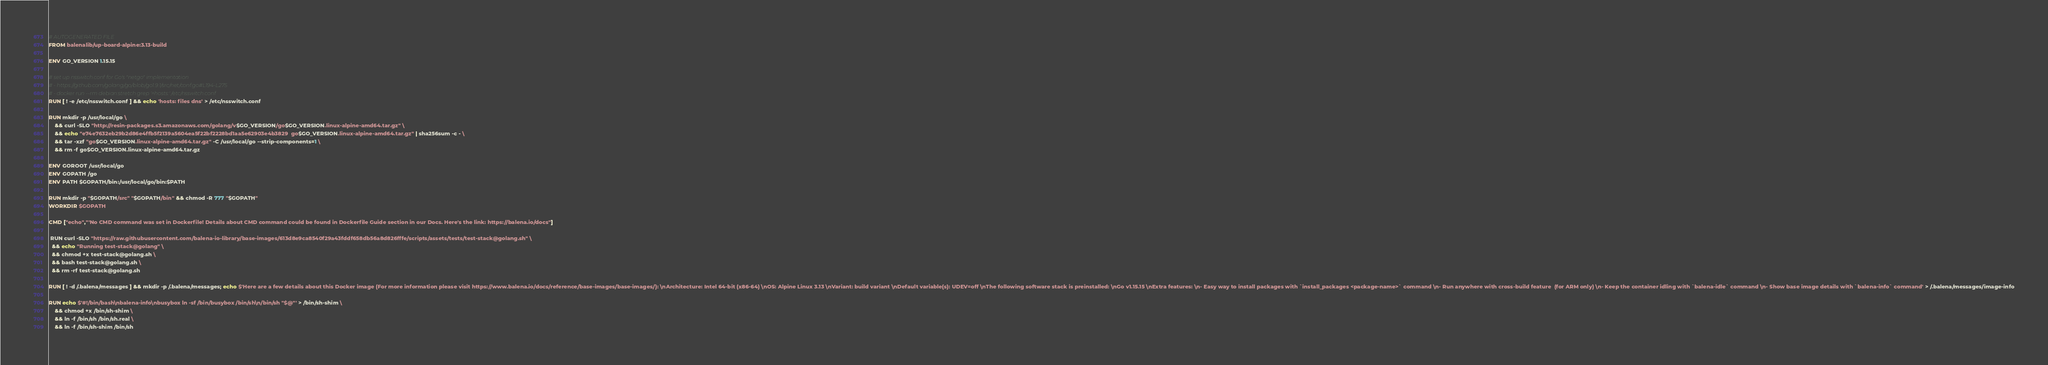<code> <loc_0><loc_0><loc_500><loc_500><_Dockerfile_># AUTOGENERATED FILE
FROM balenalib/up-board-alpine:3.13-build

ENV GO_VERSION 1.15.15

# set up nsswitch.conf for Go's "netgo" implementation
# - https://github.com/golang/go/blob/go1.9.1/src/net/conf.go#L194-L275
# - docker run --rm debian:stretch grep '^hosts:' /etc/nsswitch.conf
RUN [ ! -e /etc/nsswitch.conf ] && echo 'hosts: files dns' > /etc/nsswitch.conf

RUN mkdir -p /usr/local/go \
	&& curl -SLO "http://resin-packages.s3.amazonaws.com/golang/v$GO_VERSION/go$GO_VERSION.linux-alpine-amd64.tar.gz" \
	&& echo "e74e7632eb29b2d86e4ffb5f2139a5604ea5f22bf2228bd1aa5e62903e4b3829  go$GO_VERSION.linux-alpine-amd64.tar.gz" | sha256sum -c - \
	&& tar -xzf "go$GO_VERSION.linux-alpine-amd64.tar.gz" -C /usr/local/go --strip-components=1 \
	&& rm -f go$GO_VERSION.linux-alpine-amd64.tar.gz

ENV GOROOT /usr/local/go
ENV GOPATH /go
ENV PATH $GOPATH/bin:/usr/local/go/bin:$PATH

RUN mkdir -p "$GOPATH/src" "$GOPATH/bin" && chmod -R 777 "$GOPATH"
WORKDIR $GOPATH

CMD ["echo","'No CMD command was set in Dockerfile! Details about CMD command could be found in Dockerfile Guide section in our Docs. Here's the link: https://balena.io/docs"]

 RUN curl -SLO "https://raw.githubusercontent.com/balena-io-library/base-images/613d8e9ca8540f29a43fddf658db56a8d826fffe/scripts/assets/tests/test-stack@golang.sh" \
  && echo "Running test-stack@golang" \
  && chmod +x test-stack@golang.sh \
  && bash test-stack@golang.sh \
  && rm -rf test-stack@golang.sh 

RUN [ ! -d /.balena/messages ] && mkdir -p /.balena/messages; echo $'Here are a few details about this Docker image (For more information please visit https://www.balena.io/docs/reference/base-images/base-images/): \nArchitecture: Intel 64-bit (x86-64) \nOS: Alpine Linux 3.13 \nVariant: build variant \nDefault variable(s): UDEV=off \nThe following software stack is preinstalled: \nGo v1.15.15 \nExtra features: \n- Easy way to install packages with `install_packages <package-name>` command \n- Run anywhere with cross-build feature  (for ARM only) \n- Keep the container idling with `balena-idle` command \n- Show base image details with `balena-info` command' > /.balena/messages/image-info

RUN echo $'#!/bin/bash\nbalena-info\nbusybox ln -sf /bin/busybox /bin/sh\n/bin/sh "$@"' > /bin/sh-shim \
	&& chmod +x /bin/sh-shim \
	&& ln -f /bin/sh /bin/sh.real \
	&& ln -f /bin/sh-shim /bin/sh</code> 